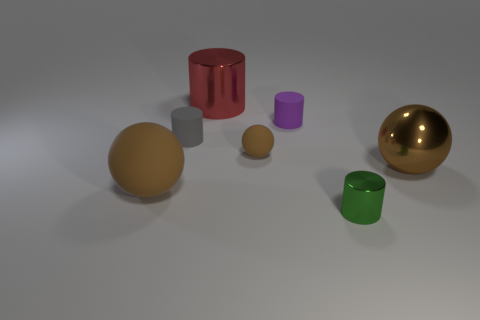Subtract all brown balls. How many were subtracted if there are1brown balls left? 2 Add 1 brown objects. How many objects exist? 8 Subtract all cylinders. How many objects are left? 3 Subtract 1 gray cylinders. How many objects are left? 6 Subtract all yellow metal cylinders. Subtract all shiny cylinders. How many objects are left? 5 Add 5 big red shiny things. How many big red shiny things are left? 6 Add 7 red cylinders. How many red cylinders exist? 8 